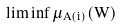<formula> <loc_0><loc_0><loc_500><loc_500>\liminf \mu _ { A ( i ) } ( W )</formula> 